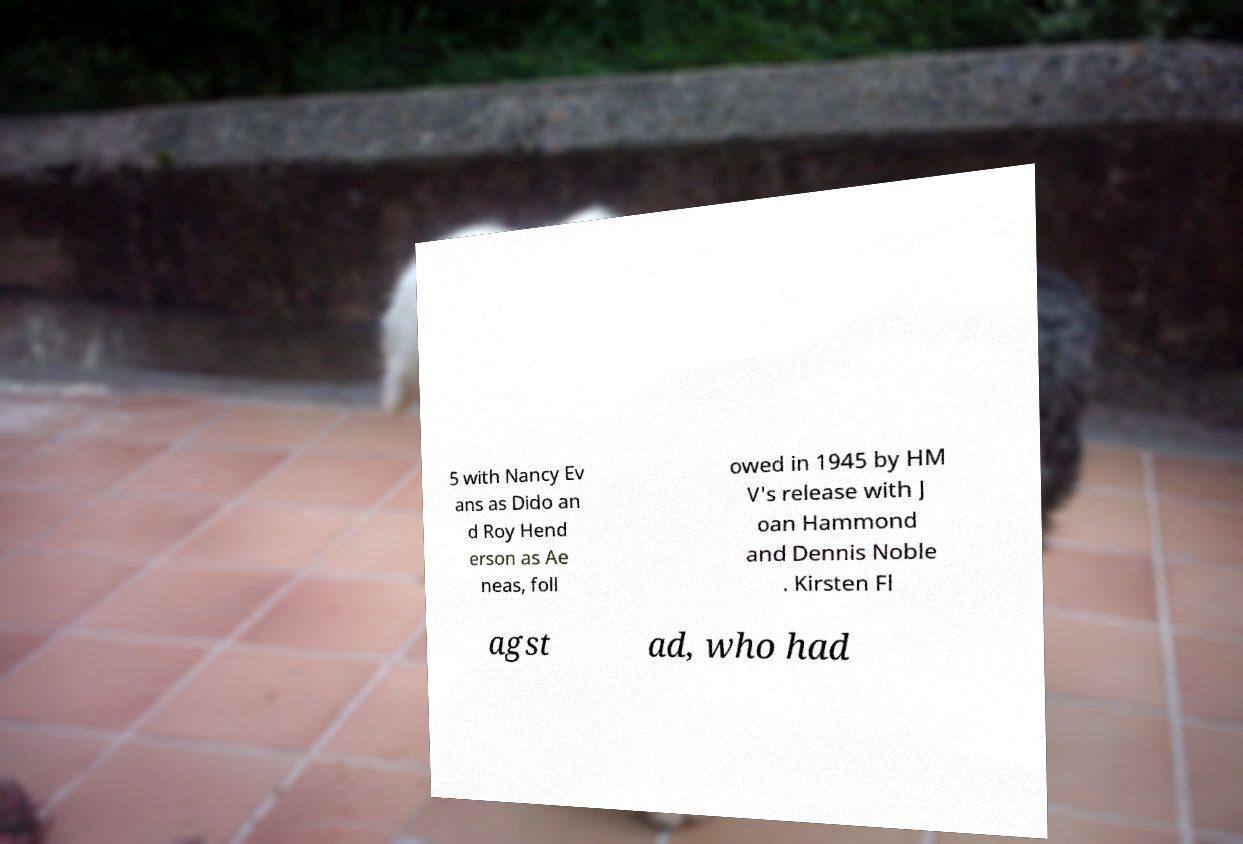Could you extract and type out the text from this image? 5 with Nancy Ev ans as Dido an d Roy Hend erson as Ae neas, foll owed in 1945 by HM V's release with J oan Hammond and Dennis Noble . Kirsten Fl agst ad, who had 